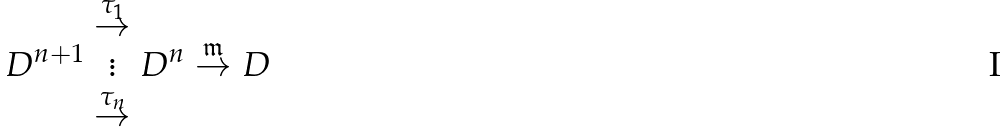<formula> <loc_0><loc_0><loc_500><loc_500>D ^ { n + 1 } \begin{array} { c } \overset { \tau _ { 1 } } { \rightarrow } \\ \vdots \\ \overset { \tau _ { n } } { \rightarrow } \end{array} D ^ { n } \overset { \mathfrak { m } } { \rightarrow } D</formula> 